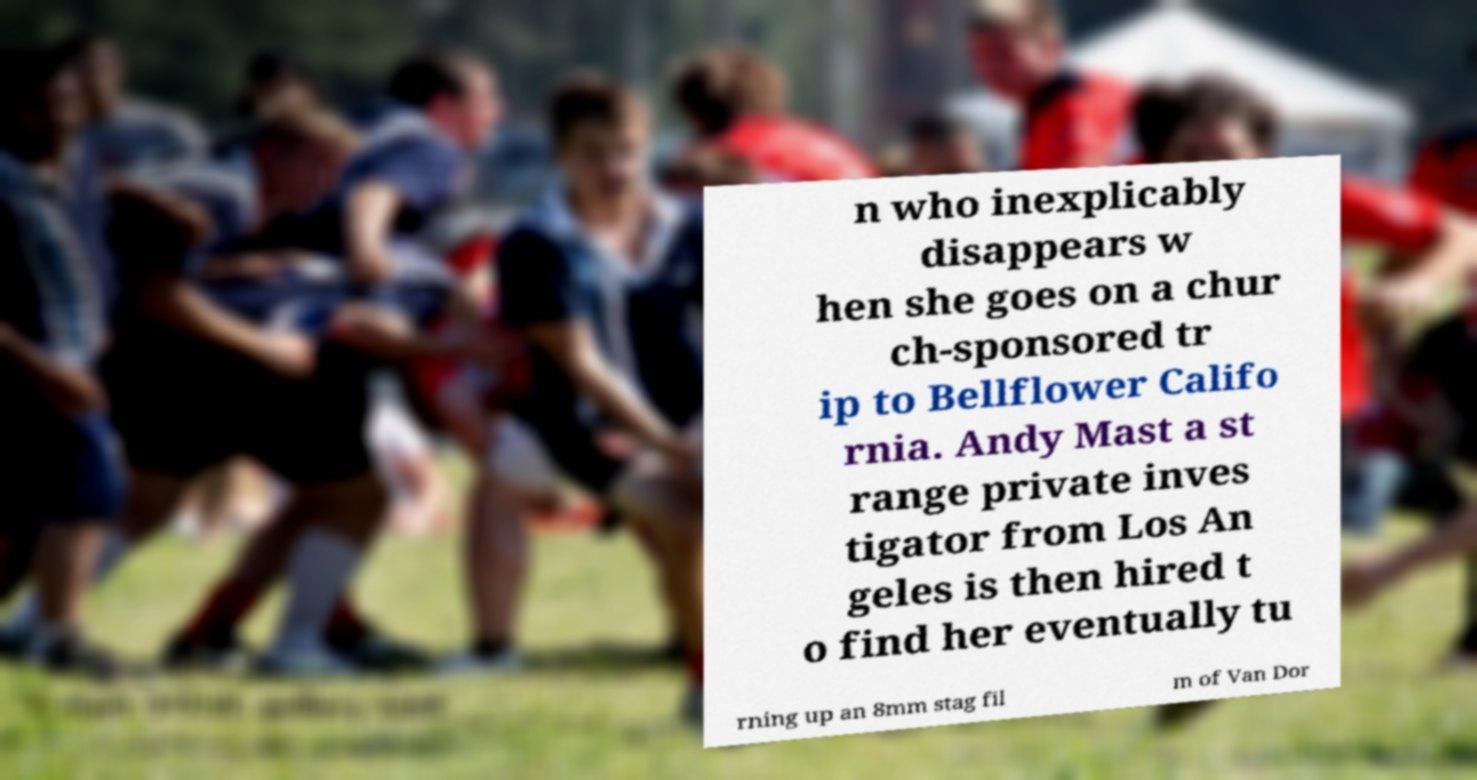I need the written content from this picture converted into text. Can you do that? n who inexplicably disappears w hen she goes on a chur ch-sponsored tr ip to Bellflower Califo rnia. Andy Mast a st range private inves tigator from Los An geles is then hired t o find her eventually tu rning up an 8mm stag fil m of Van Dor 